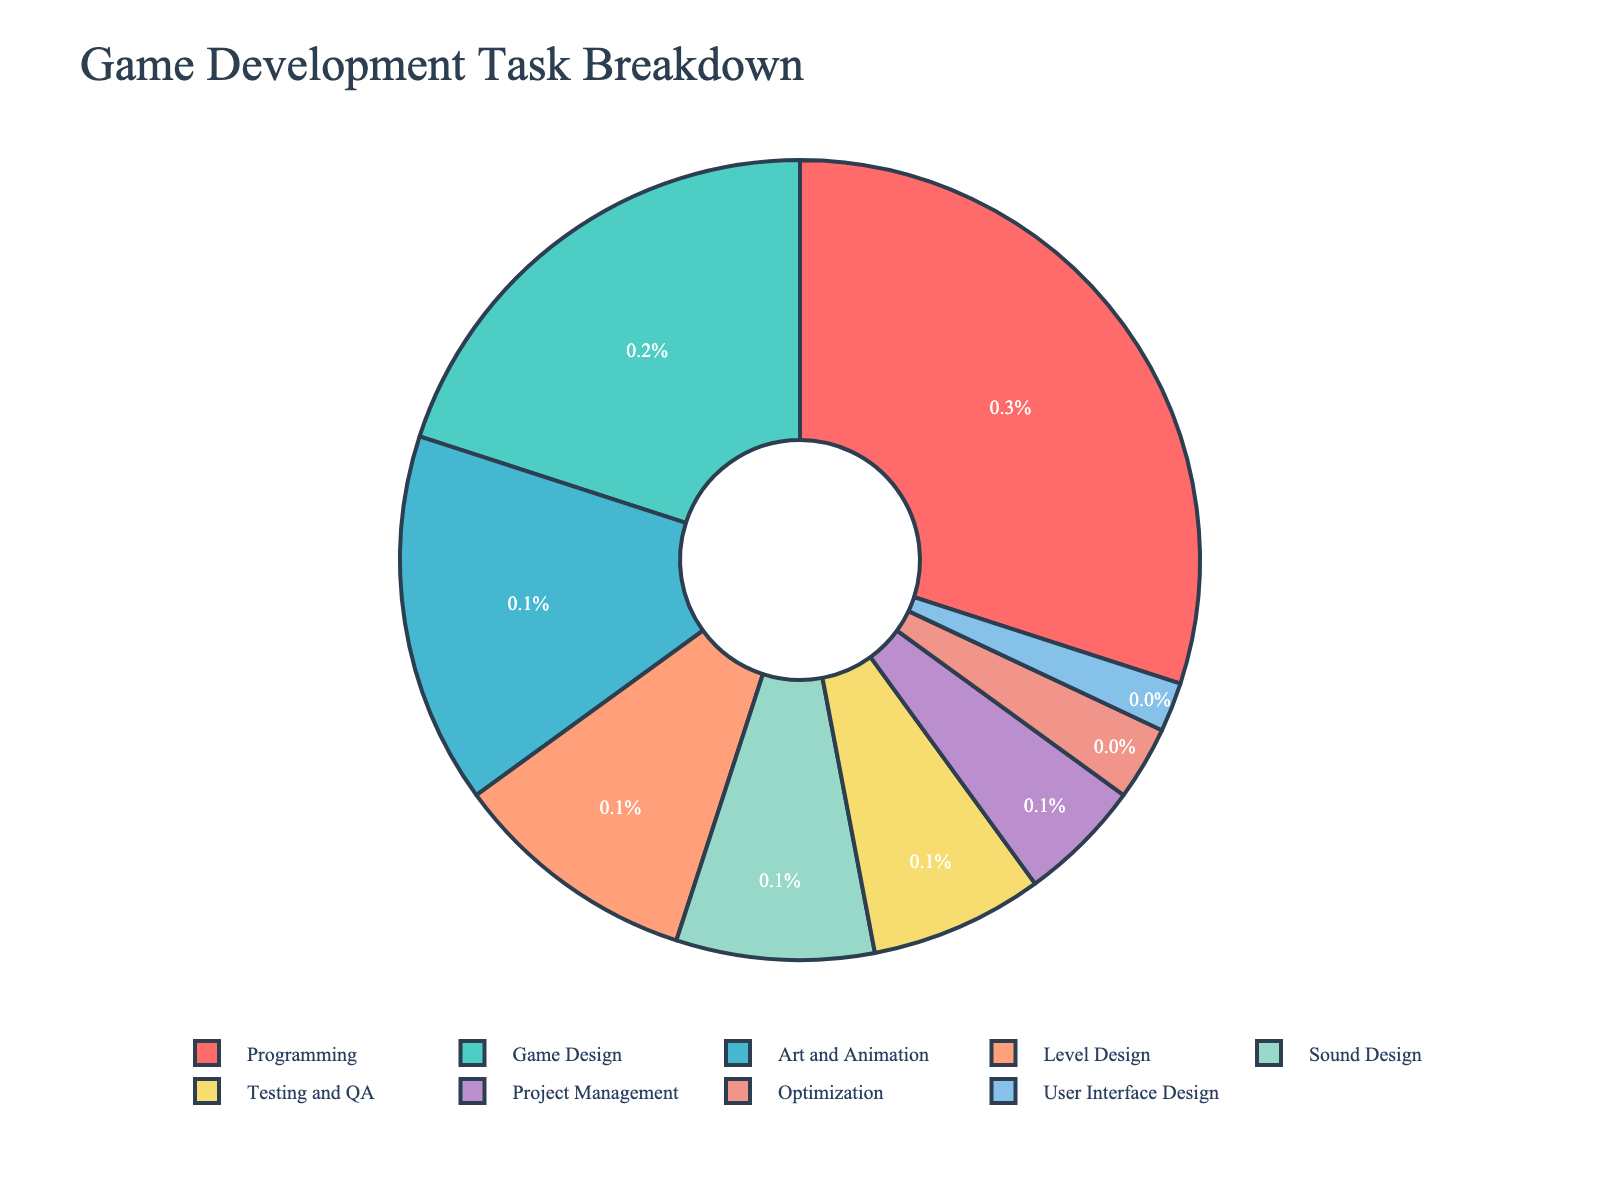What task takes up the largest percentage of time? The largest slice on the pie chart represents the task that takes up the most time. In this case, it is "Programming" with 30%.
Answer: Programming Which tasks together make up more than half of the total time spent? We need to combine the percentages until it surpasses 50%. Programming (30%) + Game Design (20%) = 50%. Adding Art and Animation (15%) makes it 65%, which is more than half.
Answer: Programming, Game Design, Art and Animation How much more time is spent on programming compared to testing and QA? Programming takes 30% of the time, and Testing and QA takes 7%. The difference is 30% - 7% = 23%.
Answer: 23% Are there more tasks that take up less than 10% or 5% of the total time? Counting tasks: Less than 10% - Level Design, Sound Design, Testing and QA, Project Management, Optimization, User Interface Design (6). Less than 5% - Project Management, Optimization, User Interface Design (3).
Answer: Less than 10% Which task has the smallest percentage of time allocated? The smallest slice on the pie chart is labeled "User Interface Design" with 2%.
Answer: User Interface Design What is the combined time for tasks related to design (Game Design, Level Design, User Interface Design)? Adding percentages: Game Design (20%) + Level Design (10%) + User Interface Design (2%) = 32%.
Answer: 32% Is more time spent on Sound Design or Art and Animation? Sound Design is 8%, while Art and Animation is 15%. 15% > 8%, so more time is spent on Art and Animation.
Answer: Art and Animation What is the percentage difference between Project Management and Optimization? Project Management is 5% and Optimization is 3%. The difference is 5% - 3% = 2%.
Answer: 2% How much time is allocated to tasks that are purely design-related? Adding percentages for design-related tasks: Game Design (20%), Level Design (10%), Art and Animation (15%), User Interface Design (2%) = 20% + 10% + 15% + 2% = 47%.
Answer: 47% Which blue-colored task represents 10% of the time? By visual inspection, the slice for Level Design is blue and represents 10%.
Answer: Level Design 